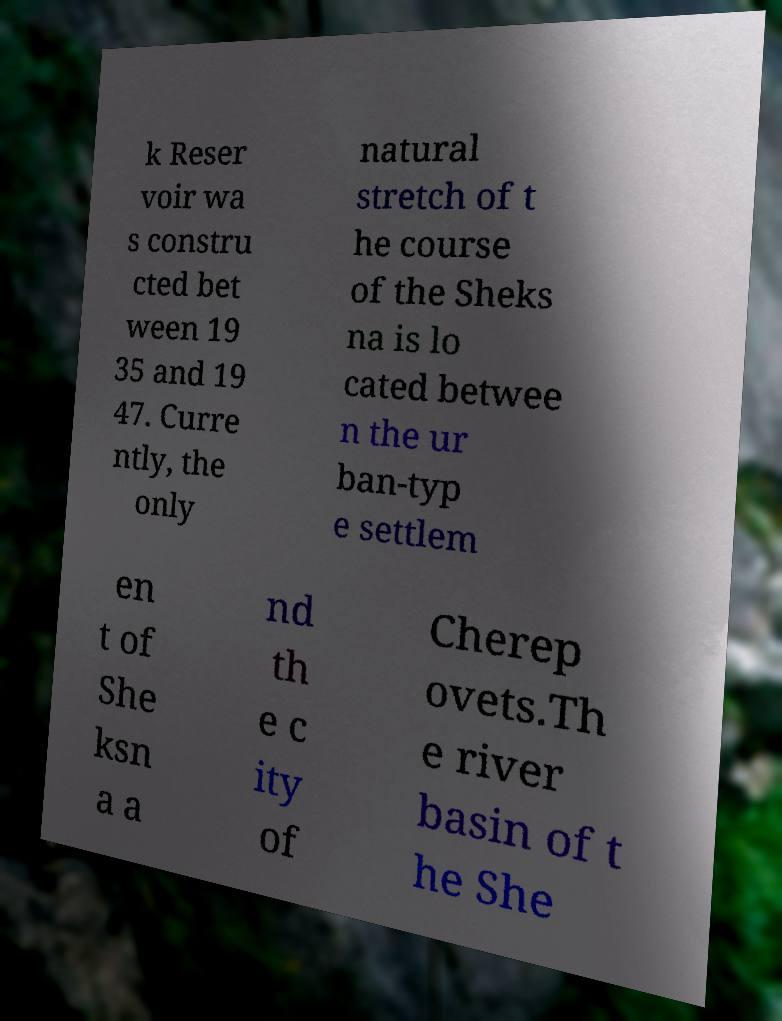For documentation purposes, I need the text within this image transcribed. Could you provide that? k Reser voir wa s constru cted bet ween 19 35 and 19 47. Curre ntly, the only natural stretch of t he course of the Sheks na is lo cated betwee n the ur ban-typ e settlem en t of She ksn a a nd th e c ity of Cherep ovets.Th e river basin of t he She 